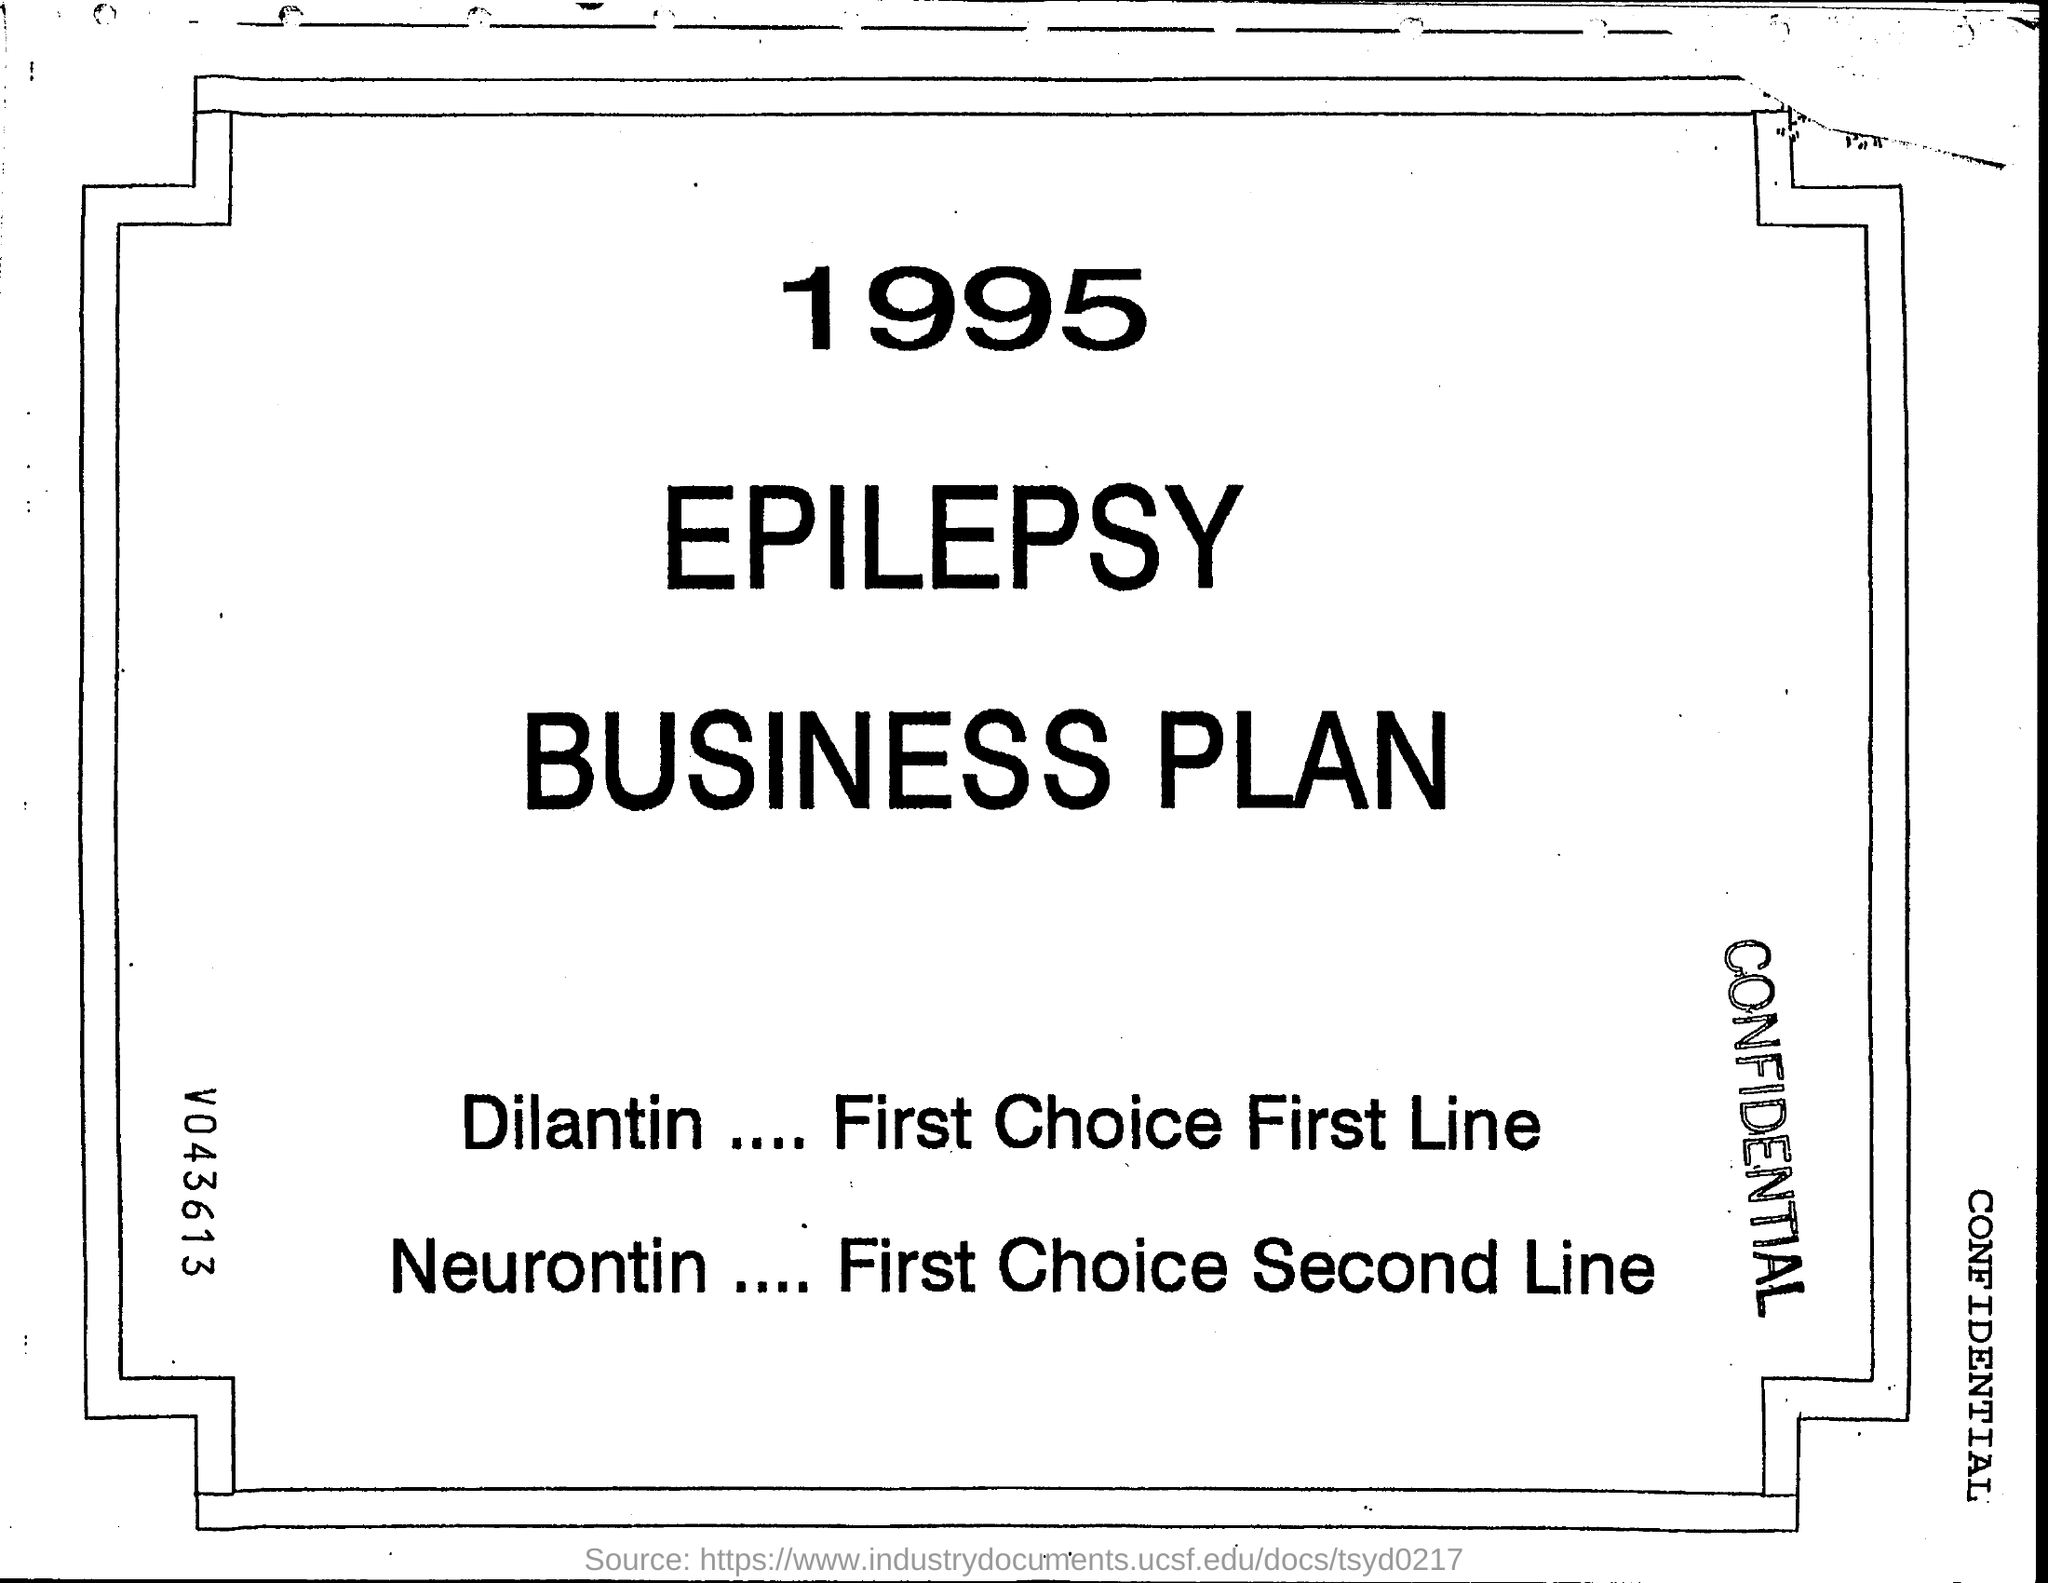What is first choice first line ?
Your response must be concise. Dilantin. What is first choice second line ?
Provide a short and direct response. Neurontin. 